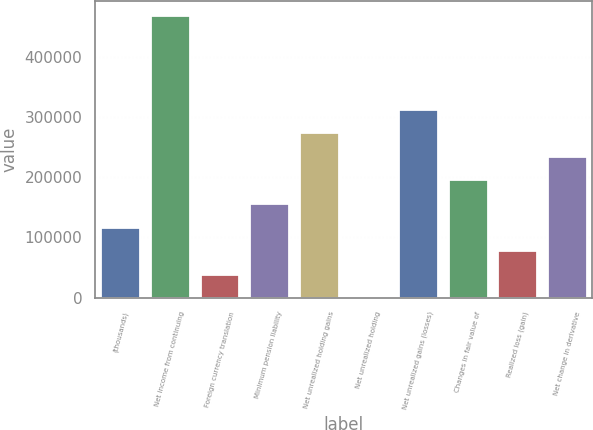Convert chart to OTSL. <chart><loc_0><loc_0><loc_500><loc_500><bar_chart><fcel>(thousands)<fcel>Net income from continuing<fcel>Foreign currency translation<fcel>Minimum pension liability<fcel>Net unrealized holding gains<fcel>Net unrealized holding<fcel>Net unrealized gains (losses)<fcel>Changes in fair value of<fcel>Realized loss (gain)<fcel>Net change in derivative<nl><fcel>118183<fcel>469943<fcel>40014.4<fcel>157268<fcel>274521<fcel>930<fcel>313605<fcel>196352<fcel>79098.8<fcel>235436<nl></chart> 